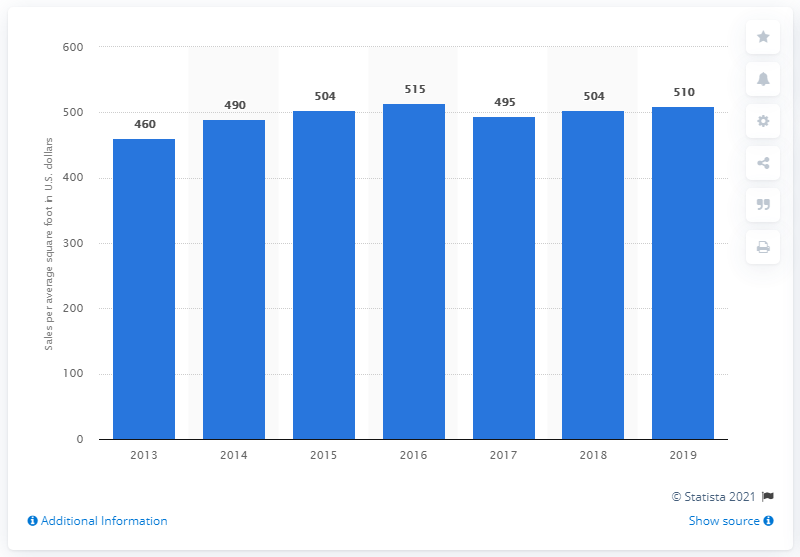Point out several critical features in this image. In 2019, Foot Locker's average gross square footage had an average sales per foot of $510. 